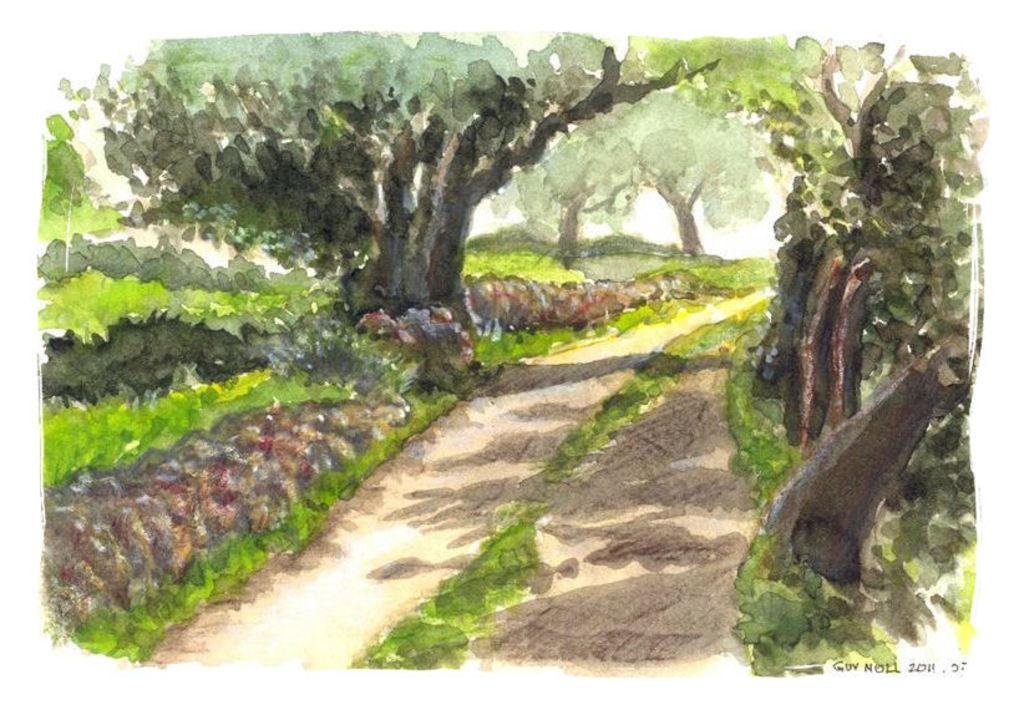What is the main subject of the image? The main subject of the image is a painting. What elements are depicted in the painting? The painting contains trees and grass. What type of key is used to unlock the owner's memory in the image? There is no key or reference to memory in the image; it only contains a painting with trees and grass. 